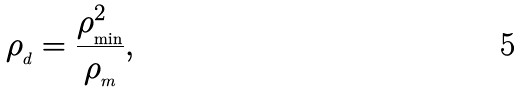<formula> <loc_0><loc_0><loc_500><loc_500>\rho _ { _ { d } } = \frac { \rho _ { _ { \min } } ^ { 2 } } { \rho _ { _ { m } } } ,</formula> 